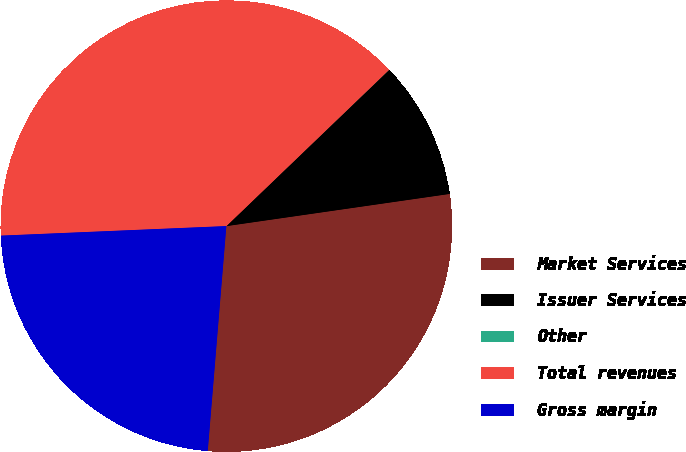<chart> <loc_0><loc_0><loc_500><loc_500><pie_chart><fcel>Market Services<fcel>Issuer Services<fcel>Other<fcel>Total revenues<fcel>Gross margin<nl><fcel>28.59%<fcel>9.89%<fcel>0.01%<fcel>38.49%<fcel>23.01%<nl></chart> 